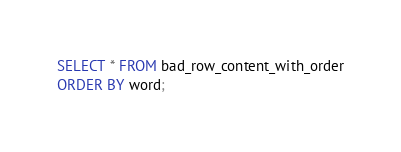Convert code to text. <code><loc_0><loc_0><loc_500><loc_500><_SQL_>SELECT * FROM bad_row_content_with_order
ORDER BY word;
</code> 